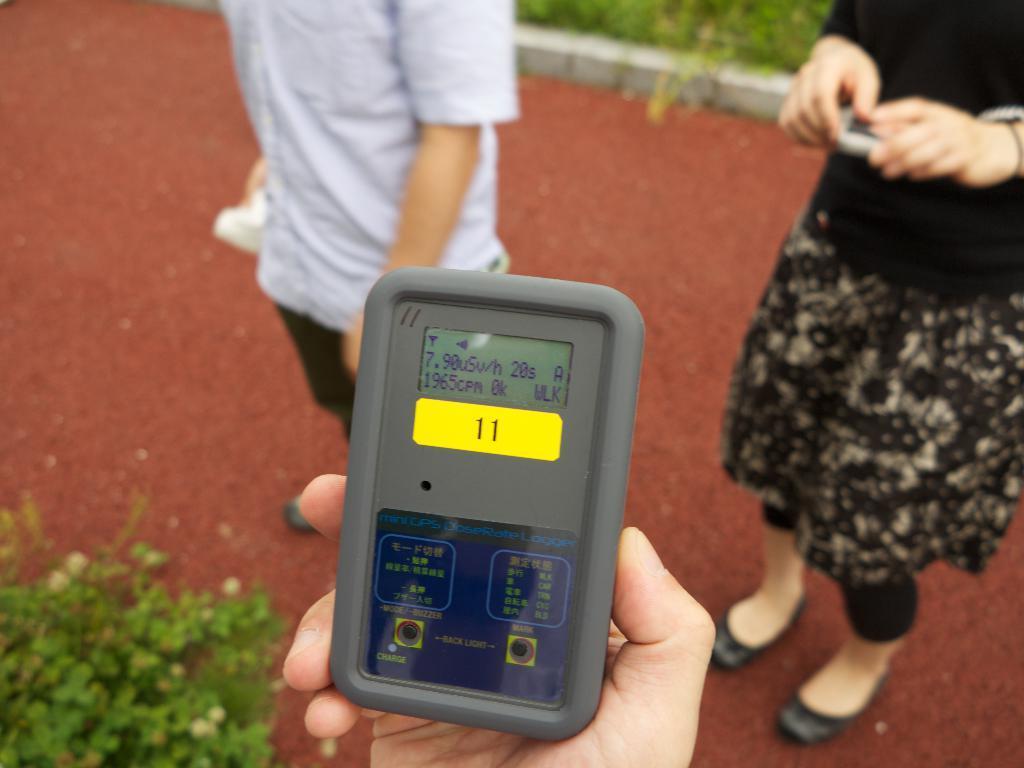Can you describe this image briefly? In this picture we can see two persons are standing, we can see another person's hand at the bottom, there is an electronic gadget present in this hand, at the left bottom there is a plant, we can see some plants at the top of the picture. 